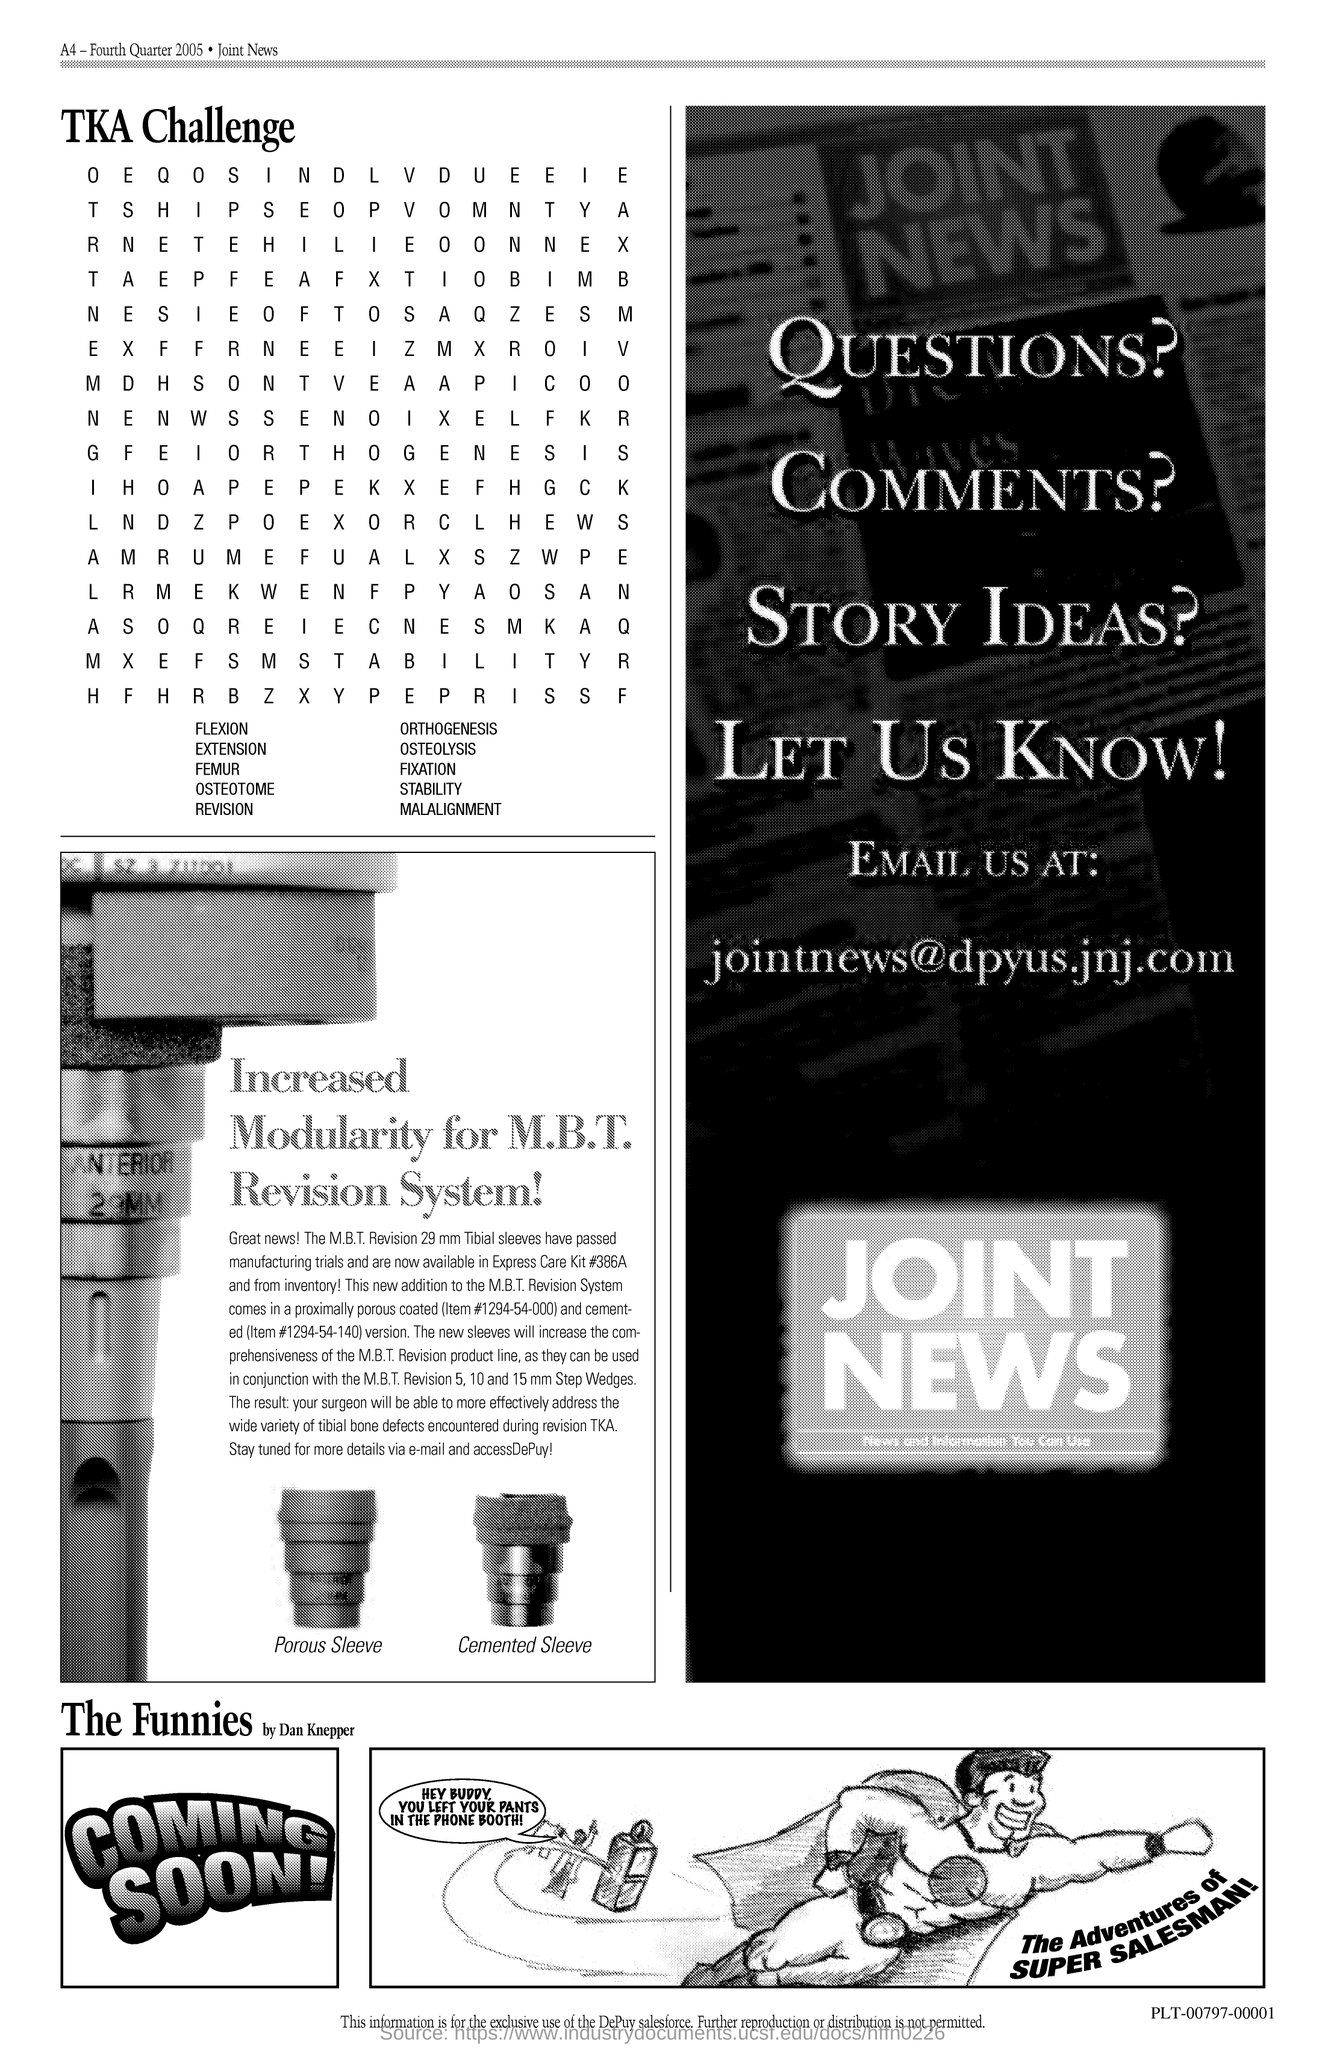What is the title that is written above the alphabets?
Your answer should be compact. TKA Challenge. 